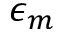Convert formula to latex. <formula><loc_0><loc_0><loc_500><loc_500>\epsilon _ { m }</formula> 